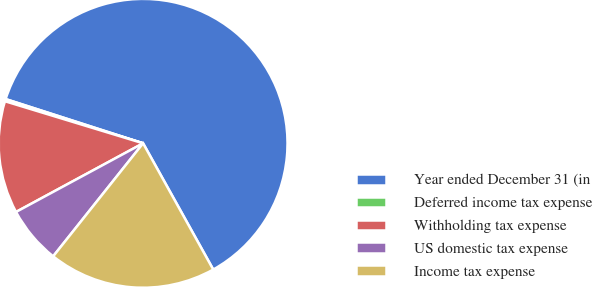Convert chart. <chart><loc_0><loc_0><loc_500><loc_500><pie_chart><fcel>Year ended December 31 (in<fcel>Deferred income tax expense<fcel>Withholding tax expense<fcel>US domestic tax expense<fcel>Income tax expense<nl><fcel>61.98%<fcel>0.25%<fcel>12.59%<fcel>6.42%<fcel>18.77%<nl></chart> 